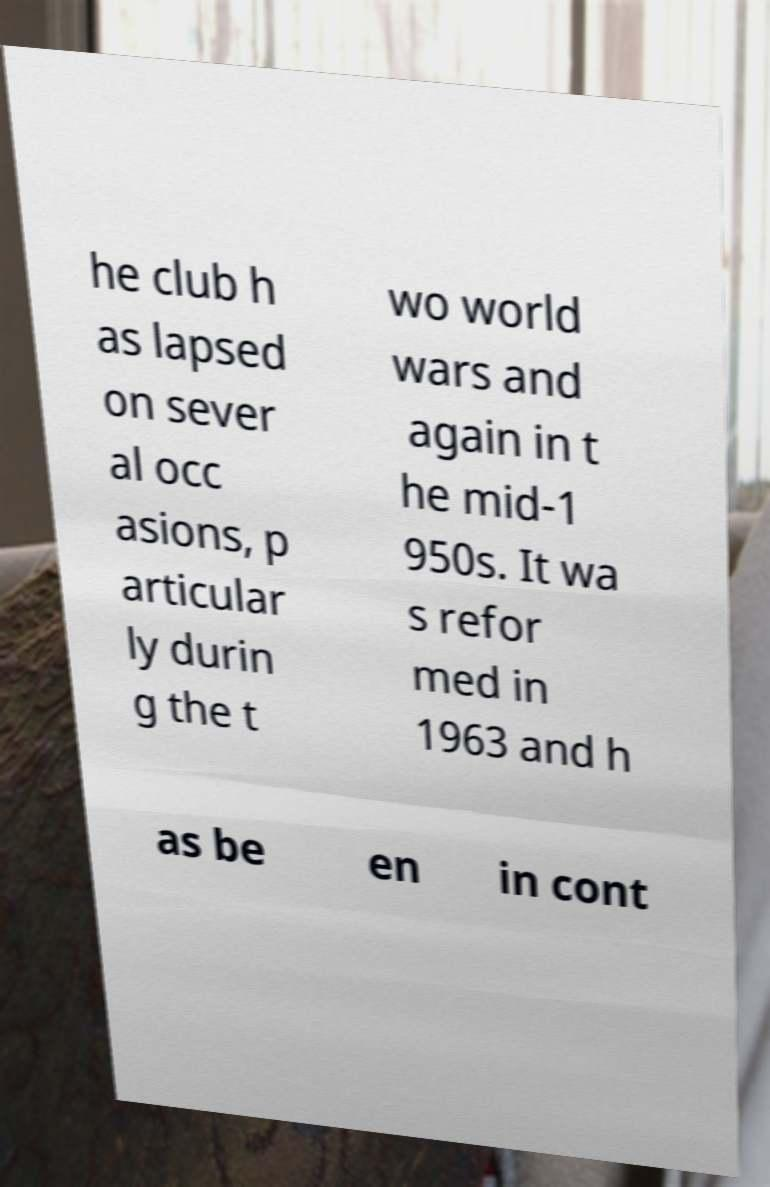What messages or text are displayed in this image? I need them in a readable, typed format. he club h as lapsed on sever al occ asions, p articular ly durin g the t wo world wars and again in t he mid-1 950s. It wa s refor med in 1963 and h as be en in cont 